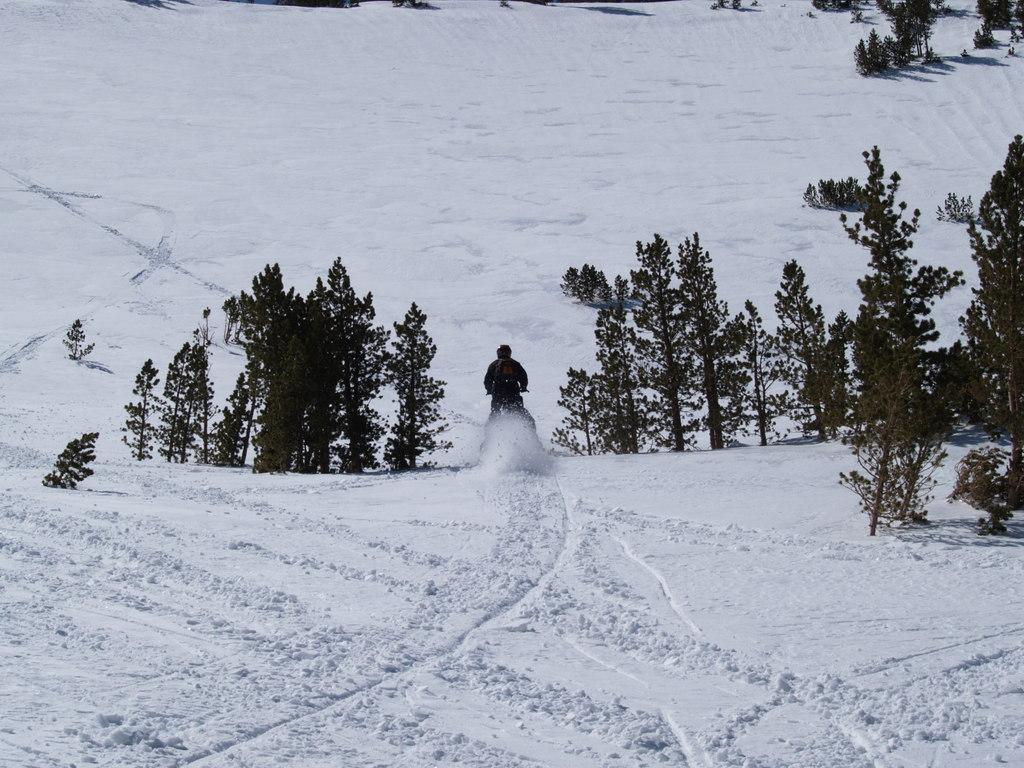What is the weather like in the image? The weather in the image is snowy. What type of natural elements can be seen in the image? There are trees in the image. What is the person in the image doing? The person is riding a vehicle in the image. In which direction is the person riding the vehicle? The person is riding the vehicle towards the back side of the image. What is the sister's face like in the image? There is no sister present in the image, so it is not possible to describe her face. 